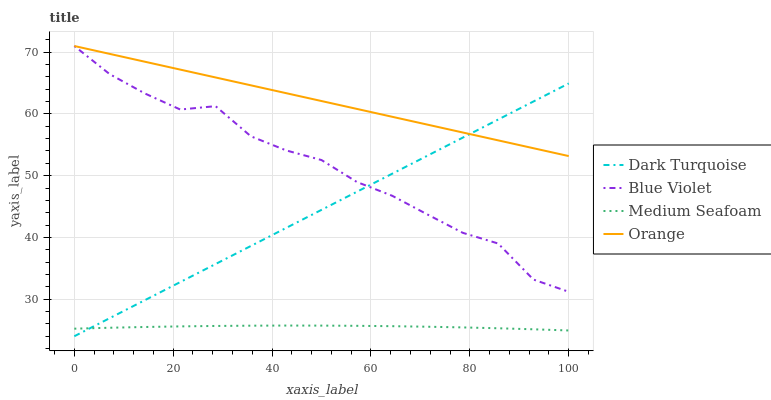Does Medium Seafoam have the minimum area under the curve?
Answer yes or no. Yes. Does Orange have the maximum area under the curve?
Answer yes or no. Yes. Does Dark Turquoise have the minimum area under the curve?
Answer yes or no. No. Does Dark Turquoise have the maximum area under the curve?
Answer yes or no. No. Is Dark Turquoise the smoothest?
Answer yes or no. Yes. Is Blue Violet the roughest?
Answer yes or no. Yes. Is Medium Seafoam the smoothest?
Answer yes or no. No. Is Medium Seafoam the roughest?
Answer yes or no. No. Does Dark Turquoise have the lowest value?
Answer yes or no. Yes. Does Medium Seafoam have the lowest value?
Answer yes or no. No. Does Blue Violet have the highest value?
Answer yes or no. Yes. Does Dark Turquoise have the highest value?
Answer yes or no. No. Is Medium Seafoam less than Blue Violet?
Answer yes or no. Yes. Is Blue Violet greater than Medium Seafoam?
Answer yes or no. Yes. Does Blue Violet intersect Orange?
Answer yes or no. Yes. Is Blue Violet less than Orange?
Answer yes or no. No. Is Blue Violet greater than Orange?
Answer yes or no. No. Does Medium Seafoam intersect Blue Violet?
Answer yes or no. No. 